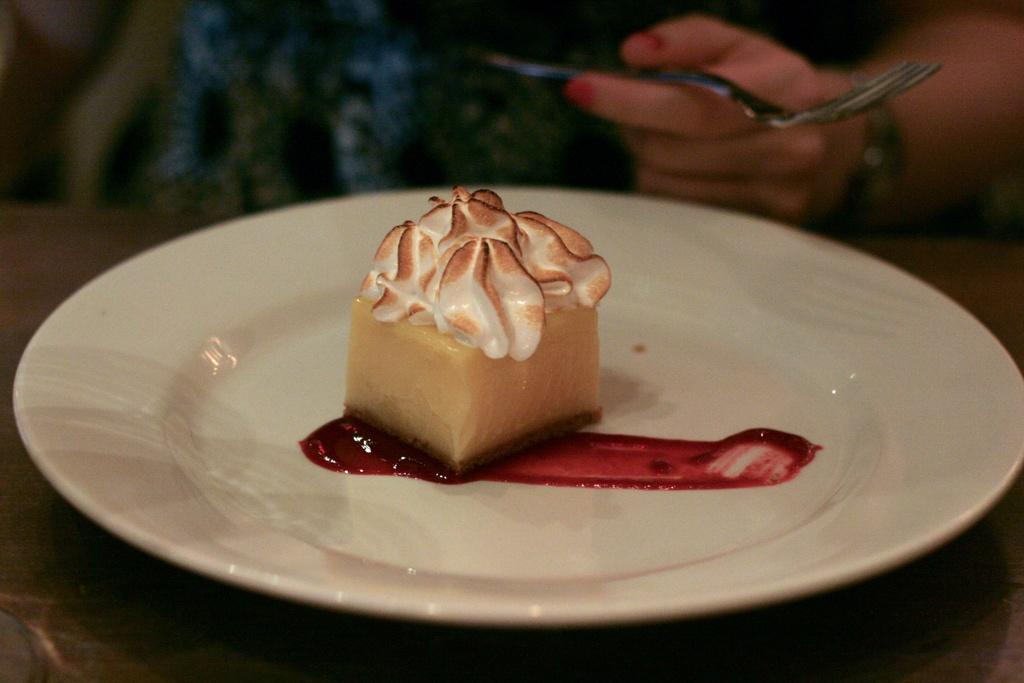What is the main subject of the image? There is a cake in the image. What is the cake placed on? The cake is on a white color plate. What can be seen on the right side of the image? A human hand is holding a fork on the right side of the image. What type of chalk is being used to draw on the yard in the image? There is no chalk or yard present in the image; it features a cake on a plate and a hand holding a fork. 